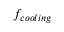Convert formula to latex. <formula><loc_0><loc_0><loc_500><loc_500>f _ { c o o l i n g }</formula> 